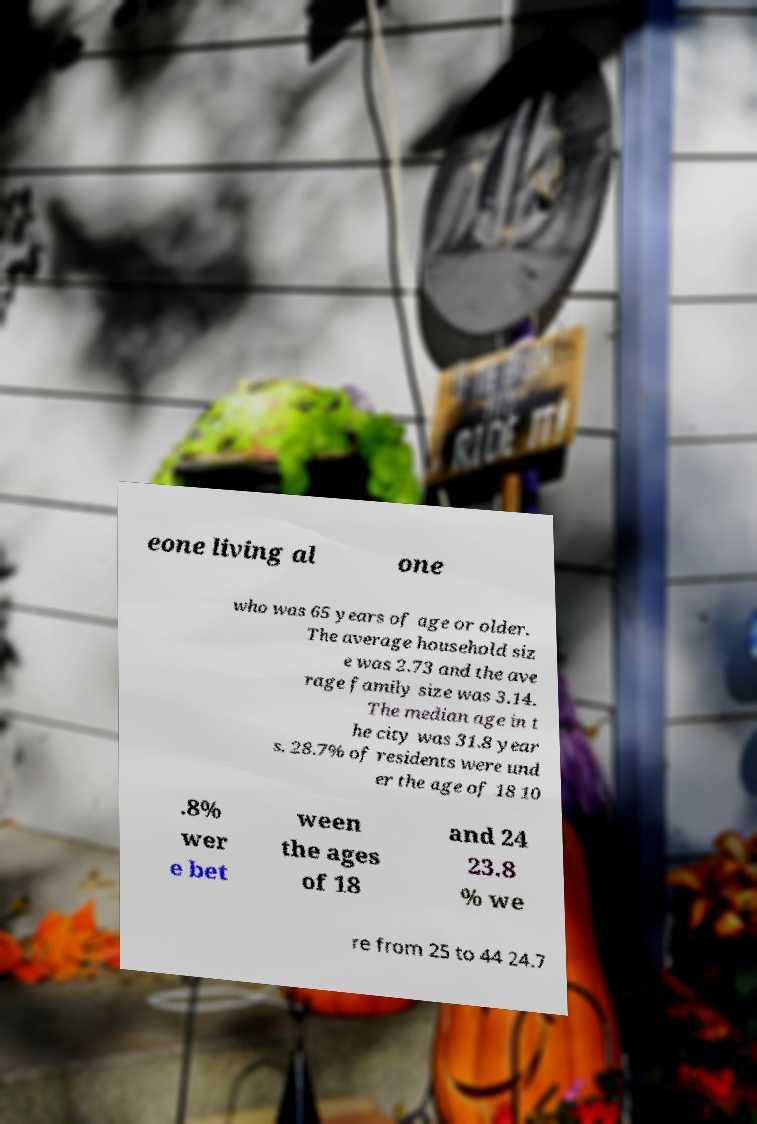What messages or text are displayed in this image? I need them in a readable, typed format. eone living al one who was 65 years of age or older. The average household siz e was 2.73 and the ave rage family size was 3.14. The median age in t he city was 31.8 year s. 28.7% of residents were und er the age of 18 10 .8% wer e bet ween the ages of 18 and 24 23.8 % we re from 25 to 44 24.7 